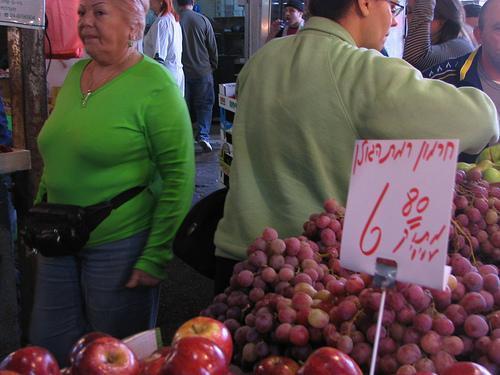How many signs are shown?
Give a very brief answer. 1. How many people can you see?
Give a very brief answer. 6. How many apples are in the picture?
Give a very brief answer. 2. 